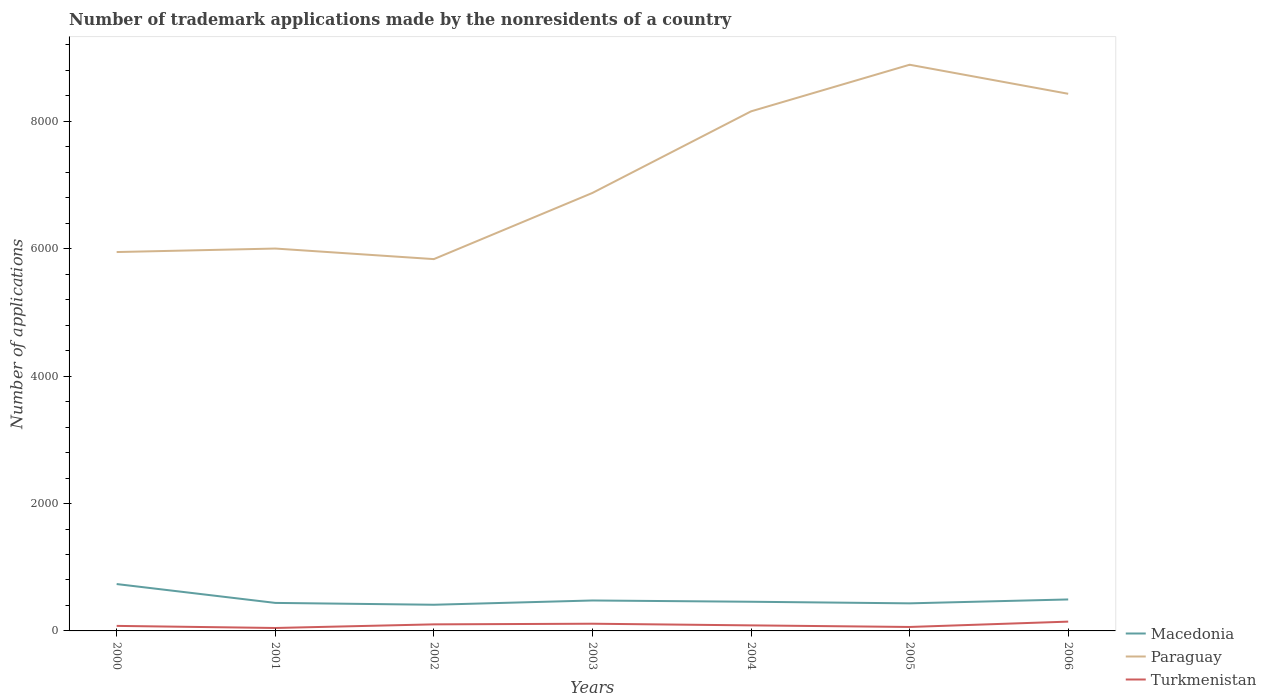How many different coloured lines are there?
Your answer should be compact. 3. Across all years, what is the maximum number of trademark applications made by the nonresidents in Macedonia?
Your answer should be compact. 411. What is the total number of trademark applications made by the nonresidents in Paraguay in the graph?
Offer a very short reply. -55. What is the difference between the highest and the second highest number of trademark applications made by the nonresidents in Paraguay?
Offer a terse response. 3052. Is the number of trademark applications made by the nonresidents in Macedonia strictly greater than the number of trademark applications made by the nonresidents in Turkmenistan over the years?
Provide a short and direct response. No. How many years are there in the graph?
Make the answer very short. 7. What is the difference between two consecutive major ticks on the Y-axis?
Provide a short and direct response. 2000. Does the graph contain any zero values?
Your answer should be very brief. No. Does the graph contain grids?
Your answer should be very brief. No. How are the legend labels stacked?
Your answer should be compact. Vertical. What is the title of the graph?
Your answer should be very brief. Number of trademark applications made by the nonresidents of a country. What is the label or title of the Y-axis?
Your response must be concise. Number of applications. What is the Number of applications of Macedonia in 2000?
Your answer should be compact. 736. What is the Number of applications in Paraguay in 2000?
Offer a terse response. 5949. What is the Number of applications in Turkmenistan in 2000?
Your answer should be very brief. 79. What is the Number of applications of Macedonia in 2001?
Provide a short and direct response. 440. What is the Number of applications in Paraguay in 2001?
Provide a short and direct response. 6004. What is the Number of applications in Macedonia in 2002?
Make the answer very short. 411. What is the Number of applications in Paraguay in 2002?
Provide a short and direct response. 5838. What is the Number of applications of Turkmenistan in 2002?
Offer a very short reply. 103. What is the Number of applications of Macedonia in 2003?
Provide a short and direct response. 478. What is the Number of applications of Paraguay in 2003?
Offer a very short reply. 6877. What is the Number of applications of Turkmenistan in 2003?
Offer a terse response. 113. What is the Number of applications in Macedonia in 2004?
Offer a very short reply. 458. What is the Number of applications of Paraguay in 2004?
Offer a very short reply. 8158. What is the Number of applications in Turkmenistan in 2004?
Offer a terse response. 87. What is the Number of applications in Macedonia in 2005?
Offer a very short reply. 433. What is the Number of applications of Paraguay in 2005?
Provide a short and direct response. 8890. What is the Number of applications of Turkmenistan in 2005?
Provide a short and direct response. 62. What is the Number of applications in Macedonia in 2006?
Your answer should be very brief. 494. What is the Number of applications in Paraguay in 2006?
Provide a succinct answer. 8434. What is the Number of applications in Turkmenistan in 2006?
Your answer should be compact. 146. Across all years, what is the maximum Number of applications in Macedonia?
Your response must be concise. 736. Across all years, what is the maximum Number of applications in Paraguay?
Offer a very short reply. 8890. Across all years, what is the maximum Number of applications in Turkmenistan?
Your answer should be compact. 146. Across all years, what is the minimum Number of applications in Macedonia?
Offer a very short reply. 411. Across all years, what is the minimum Number of applications of Paraguay?
Your response must be concise. 5838. Across all years, what is the minimum Number of applications in Turkmenistan?
Provide a succinct answer. 46. What is the total Number of applications of Macedonia in the graph?
Provide a succinct answer. 3450. What is the total Number of applications in Paraguay in the graph?
Your answer should be very brief. 5.02e+04. What is the total Number of applications of Turkmenistan in the graph?
Your answer should be compact. 636. What is the difference between the Number of applications in Macedonia in 2000 and that in 2001?
Make the answer very short. 296. What is the difference between the Number of applications of Paraguay in 2000 and that in 2001?
Provide a succinct answer. -55. What is the difference between the Number of applications in Turkmenistan in 2000 and that in 2001?
Give a very brief answer. 33. What is the difference between the Number of applications of Macedonia in 2000 and that in 2002?
Your answer should be compact. 325. What is the difference between the Number of applications in Paraguay in 2000 and that in 2002?
Offer a terse response. 111. What is the difference between the Number of applications in Turkmenistan in 2000 and that in 2002?
Provide a short and direct response. -24. What is the difference between the Number of applications of Macedonia in 2000 and that in 2003?
Offer a very short reply. 258. What is the difference between the Number of applications of Paraguay in 2000 and that in 2003?
Provide a short and direct response. -928. What is the difference between the Number of applications of Turkmenistan in 2000 and that in 2003?
Give a very brief answer. -34. What is the difference between the Number of applications of Macedonia in 2000 and that in 2004?
Keep it short and to the point. 278. What is the difference between the Number of applications of Paraguay in 2000 and that in 2004?
Your answer should be compact. -2209. What is the difference between the Number of applications in Turkmenistan in 2000 and that in 2004?
Offer a very short reply. -8. What is the difference between the Number of applications in Macedonia in 2000 and that in 2005?
Your answer should be very brief. 303. What is the difference between the Number of applications of Paraguay in 2000 and that in 2005?
Your response must be concise. -2941. What is the difference between the Number of applications in Turkmenistan in 2000 and that in 2005?
Provide a short and direct response. 17. What is the difference between the Number of applications in Macedonia in 2000 and that in 2006?
Make the answer very short. 242. What is the difference between the Number of applications of Paraguay in 2000 and that in 2006?
Make the answer very short. -2485. What is the difference between the Number of applications in Turkmenistan in 2000 and that in 2006?
Make the answer very short. -67. What is the difference between the Number of applications of Macedonia in 2001 and that in 2002?
Provide a succinct answer. 29. What is the difference between the Number of applications in Paraguay in 2001 and that in 2002?
Keep it short and to the point. 166. What is the difference between the Number of applications of Turkmenistan in 2001 and that in 2002?
Offer a very short reply. -57. What is the difference between the Number of applications in Macedonia in 2001 and that in 2003?
Your response must be concise. -38. What is the difference between the Number of applications in Paraguay in 2001 and that in 2003?
Your answer should be compact. -873. What is the difference between the Number of applications in Turkmenistan in 2001 and that in 2003?
Make the answer very short. -67. What is the difference between the Number of applications of Macedonia in 2001 and that in 2004?
Keep it short and to the point. -18. What is the difference between the Number of applications in Paraguay in 2001 and that in 2004?
Your answer should be very brief. -2154. What is the difference between the Number of applications of Turkmenistan in 2001 and that in 2004?
Your answer should be compact. -41. What is the difference between the Number of applications of Macedonia in 2001 and that in 2005?
Ensure brevity in your answer.  7. What is the difference between the Number of applications in Paraguay in 2001 and that in 2005?
Make the answer very short. -2886. What is the difference between the Number of applications of Macedonia in 2001 and that in 2006?
Give a very brief answer. -54. What is the difference between the Number of applications of Paraguay in 2001 and that in 2006?
Keep it short and to the point. -2430. What is the difference between the Number of applications in Turkmenistan in 2001 and that in 2006?
Offer a terse response. -100. What is the difference between the Number of applications in Macedonia in 2002 and that in 2003?
Provide a short and direct response. -67. What is the difference between the Number of applications of Paraguay in 2002 and that in 2003?
Provide a short and direct response. -1039. What is the difference between the Number of applications in Macedonia in 2002 and that in 2004?
Provide a short and direct response. -47. What is the difference between the Number of applications of Paraguay in 2002 and that in 2004?
Provide a succinct answer. -2320. What is the difference between the Number of applications of Paraguay in 2002 and that in 2005?
Provide a succinct answer. -3052. What is the difference between the Number of applications of Macedonia in 2002 and that in 2006?
Offer a terse response. -83. What is the difference between the Number of applications in Paraguay in 2002 and that in 2006?
Provide a short and direct response. -2596. What is the difference between the Number of applications of Turkmenistan in 2002 and that in 2006?
Give a very brief answer. -43. What is the difference between the Number of applications in Macedonia in 2003 and that in 2004?
Ensure brevity in your answer.  20. What is the difference between the Number of applications of Paraguay in 2003 and that in 2004?
Provide a short and direct response. -1281. What is the difference between the Number of applications of Macedonia in 2003 and that in 2005?
Ensure brevity in your answer.  45. What is the difference between the Number of applications in Paraguay in 2003 and that in 2005?
Your answer should be compact. -2013. What is the difference between the Number of applications in Macedonia in 2003 and that in 2006?
Offer a terse response. -16. What is the difference between the Number of applications of Paraguay in 2003 and that in 2006?
Your answer should be compact. -1557. What is the difference between the Number of applications of Turkmenistan in 2003 and that in 2006?
Your answer should be very brief. -33. What is the difference between the Number of applications in Paraguay in 2004 and that in 2005?
Provide a succinct answer. -732. What is the difference between the Number of applications of Macedonia in 2004 and that in 2006?
Offer a terse response. -36. What is the difference between the Number of applications in Paraguay in 2004 and that in 2006?
Provide a short and direct response. -276. What is the difference between the Number of applications in Turkmenistan in 2004 and that in 2006?
Make the answer very short. -59. What is the difference between the Number of applications of Macedonia in 2005 and that in 2006?
Keep it short and to the point. -61. What is the difference between the Number of applications of Paraguay in 2005 and that in 2006?
Provide a short and direct response. 456. What is the difference between the Number of applications of Turkmenistan in 2005 and that in 2006?
Offer a terse response. -84. What is the difference between the Number of applications of Macedonia in 2000 and the Number of applications of Paraguay in 2001?
Offer a terse response. -5268. What is the difference between the Number of applications in Macedonia in 2000 and the Number of applications in Turkmenistan in 2001?
Your response must be concise. 690. What is the difference between the Number of applications in Paraguay in 2000 and the Number of applications in Turkmenistan in 2001?
Provide a short and direct response. 5903. What is the difference between the Number of applications in Macedonia in 2000 and the Number of applications in Paraguay in 2002?
Ensure brevity in your answer.  -5102. What is the difference between the Number of applications of Macedonia in 2000 and the Number of applications of Turkmenistan in 2002?
Provide a succinct answer. 633. What is the difference between the Number of applications of Paraguay in 2000 and the Number of applications of Turkmenistan in 2002?
Provide a short and direct response. 5846. What is the difference between the Number of applications in Macedonia in 2000 and the Number of applications in Paraguay in 2003?
Provide a short and direct response. -6141. What is the difference between the Number of applications of Macedonia in 2000 and the Number of applications of Turkmenistan in 2003?
Offer a terse response. 623. What is the difference between the Number of applications of Paraguay in 2000 and the Number of applications of Turkmenistan in 2003?
Provide a succinct answer. 5836. What is the difference between the Number of applications in Macedonia in 2000 and the Number of applications in Paraguay in 2004?
Offer a very short reply. -7422. What is the difference between the Number of applications in Macedonia in 2000 and the Number of applications in Turkmenistan in 2004?
Your response must be concise. 649. What is the difference between the Number of applications of Paraguay in 2000 and the Number of applications of Turkmenistan in 2004?
Provide a succinct answer. 5862. What is the difference between the Number of applications in Macedonia in 2000 and the Number of applications in Paraguay in 2005?
Ensure brevity in your answer.  -8154. What is the difference between the Number of applications of Macedonia in 2000 and the Number of applications of Turkmenistan in 2005?
Make the answer very short. 674. What is the difference between the Number of applications in Paraguay in 2000 and the Number of applications in Turkmenistan in 2005?
Make the answer very short. 5887. What is the difference between the Number of applications in Macedonia in 2000 and the Number of applications in Paraguay in 2006?
Ensure brevity in your answer.  -7698. What is the difference between the Number of applications of Macedonia in 2000 and the Number of applications of Turkmenistan in 2006?
Offer a terse response. 590. What is the difference between the Number of applications in Paraguay in 2000 and the Number of applications in Turkmenistan in 2006?
Provide a short and direct response. 5803. What is the difference between the Number of applications of Macedonia in 2001 and the Number of applications of Paraguay in 2002?
Provide a short and direct response. -5398. What is the difference between the Number of applications in Macedonia in 2001 and the Number of applications in Turkmenistan in 2002?
Your answer should be very brief. 337. What is the difference between the Number of applications in Paraguay in 2001 and the Number of applications in Turkmenistan in 2002?
Offer a terse response. 5901. What is the difference between the Number of applications in Macedonia in 2001 and the Number of applications in Paraguay in 2003?
Make the answer very short. -6437. What is the difference between the Number of applications in Macedonia in 2001 and the Number of applications in Turkmenistan in 2003?
Your answer should be very brief. 327. What is the difference between the Number of applications in Paraguay in 2001 and the Number of applications in Turkmenistan in 2003?
Your answer should be compact. 5891. What is the difference between the Number of applications of Macedonia in 2001 and the Number of applications of Paraguay in 2004?
Provide a succinct answer. -7718. What is the difference between the Number of applications in Macedonia in 2001 and the Number of applications in Turkmenistan in 2004?
Make the answer very short. 353. What is the difference between the Number of applications in Paraguay in 2001 and the Number of applications in Turkmenistan in 2004?
Ensure brevity in your answer.  5917. What is the difference between the Number of applications in Macedonia in 2001 and the Number of applications in Paraguay in 2005?
Make the answer very short. -8450. What is the difference between the Number of applications in Macedonia in 2001 and the Number of applications in Turkmenistan in 2005?
Keep it short and to the point. 378. What is the difference between the Number of applications of Paraguay in 2001 and the Number of applications of Turkmenistan in 2005?
Provide a short and direct response. 5942. What is the difference between the Number of applications of Macedonia in 2001 and the Number of applications of Paraguay in 2006?
Your answer should be very brief. -7994. What is the difference between the Number of applications of Macedonia in 2001 and the Number of applications of Turkmenistan in 2006?
Your answer should be compact. 294. What is the difference between the Number of applications of Paraguay in 2001 and the Number of applications of Turkmenistan in 2006?
Provide a short and direct response. 5858. What is the difference between the Number of applications of Macedonia in 2002 and the Number of applications of Paraguay in 2003?
Your response must be concise. -6466. What is the difference between the Number of applications in Macedonia in 2002 and the Number of applications in Turkmenistan in 2003?
Give a very brief answer. 298. What is the difference between the Number of applications in Paraguay in 2002 and the Number of applications in Turkmenistan in 2003?
Make the answer very short. 5725. What is the difference between the Number of applications in Macedonia in 2002 and the Number of applications in Paraguay in 2004?
Keep it short and to the point. -7747. What is the difference between the Number of applications in Macedonia in 2002 and the Number of applications in Turkmenistan in 2004?
Make the answer very short. 324. What is the difference between the Number of applications of Paraguay in 2002 and the Number of applications of Turkmenistan in 2004?
Make the answer very short. 5751. What is the difference between the Number of applications of Macedonia in 2002 and the Number of applications of Paraguay in 2005?
Offer a very short reply. -8479. What is the difference between the Number of applications of Macedonia in 2002 and the Number of applications of Turkmenistan in 2005?
Ensure brevity in your answer.  349. What is the difference between the Number of applications of Paraguay in 2002 and the Number of applications of Turkmenistan in 2005?
Provide a short and direct response. 5776. What is the difference between the Number of applications of Macedonia in 2002 and the Number of applications of Paraguay in 2006?
Keep it short and to the point. -8023. What is the difference between the Number of applications of Macedonia in 2002 and the Number of applications of Turkmenistan in 2006?
Your answer should be very brief. 265. What is the difference between the Number of applications of Paraguay in 2002 and the Number of applications of Turkmenistan in 2006?
Give a very brief answer. 5692. What is the difference between the Number of applications in Macedonia in 2003 and the Number of applications in Paraguay in 2004?
Your answer should be very brief. -7680. What is the difference between the Number of applications of Macedonia in 2003 and the Number of applications of Turkmenistan in 2004?
Provide a short and direct response. 391. What is the difference between the Number of applications in Paraguay in 2003 and the Number of applications in Turkmenistan in 2004?
Offer a terse response. 6790. What is the difference between the Number of applications of Macedonia in 2003 and the Number of applications of Paraguay in 2005?
Keep it short and to the point. -8412. What is the difference between the Number of applications of Macedonia in 2003 and the Number of applications of Turkmenistan in 2005?
Your response must be concise. 416. What is the difference between the Number of applications of Paraguay in 2003 and the Number of applications of Turkmenistan in 2005?
Give a very brief answer. 6815. What is the difference between the Number of applications in Macedonia in 2003 and the Number of applications in Paraguay in 2006?
Offer a very short reply. -7956. What is the difference between the Number of applications in Macedonia in 2003 and the Number of applications in Turkmenistan in 2006?
Your answer should be very brief. 332. What is the difference between the Number of applications of Paraguay in 2003 and the Number of applications of Turkmenistan in 2006?
Keep it short and to the point. 6731. What is the difference between the Number of applications in Macedonia in 2004 and the Number of applications in Paraguay in 2005?
Your answer should be compact. -8432. What is the difference between the Number of applications of Macedonia in 2004 and the Number of applications of Turkmenistan in 2005?
Provide a succinct answer. 396. What is the difference between the Number of applications of Paraguay in 2004 and the Number of applications of Turkmenistan in 2005?
Keep it short and to the point. 8096. What is the difference between the Number of applications in Macedonia in 2004 and the Number of applications in Paraguay in 2006?
Give a very brief answer. -7976. What is the difference between the Number of applications in Macedonia in 2004 and the Number of applications in Turkmenistan in 2006?
Give a very brief answer. 312. What is the difference between the Number of applications in Paraguay in 2004 and the Number of applications in Turkmenistan in 2006?
Make the answer very short. 8012. What is the difference between the Number of applications of Macedonia in 2005 and the Number of applications of Paraguay in 2006?
Your answer should be very brief. -8001. What is the difference between the Number of applications of Macedonia in 2005 and the Number of applications of Turkmenistan in 2006?
Your answer should be very brief. 287. What is the difference between the Number of applications of Paraguay in 2005 and the Number of applications of Turkmenistan in 2006?
Ensure brevity in your answer.  8744. What is the average Number of applications of Macedonia per year?
Your answer should be compact. 492.86. What is the average Number of applications of Paraguay per year?
Your answer should be very brief. 7164.29. What is the average Number of applications of Turkmenistan per year?
Offer a very short reply. 90.86. In the year 2000, what is the difference between the Number of applications of Macedonia and Number of applications of Paraguay?
Make the answer very short. -5213. In the year 2000, what is the difference between the Number of applications in Macedonia and Number of applications in Turkmenistan?
Make the answer very short. 657. In the year 2000, what is the difference between the Number of applications of Paraguay and Number of applications of Turkmenistan?
Provide a short and direct response. 5870. In the year 2001, what is the difference between the Number of applications in Macedonia and Number of applications in Paraguay?
Make the answer very short. -5564. In the year 2001, what is the difference between the Number of applications in Macedonia and Number of applications in Turkmenistan?
Your answer should be very brief. 394. In the year 2001, what is the difference between the Number of applications in Paraguay and Number of applications in Turkmenistan?
Offer a terse response. 5958. In the year 2002, what is the difference between the Number of applications of Macedonia and Number of applications of Paraguay?
Make the answer very short. -5427. In the year 2002, what is the difference between the Number of applications in Macedonia and Number of applications in Turkmenistan?
Your answer should be compact. 308. In the year 2002, what is the difference between the Number of applications in Paraguay and Number of applications in Turkmenistan?
Your answer should be very brief. 5735. In the year 2003, what is the difference between the Number of applications in Macedonia and Number of applications in Paraguay?
Ensure brevity in your answer.  -6399. In the year 2003, what is the difference between the Number of applications in Macedonia and Number of applications in Turkmenistan?
Provide a succinct answer. 365. In the year 2003, what is the difference between the Number of applications of Paraguay and Number of applications of Turkmenistan?
Provide a short and direct response. 6764. In the year 2004, what is the difference between the Number of applications of Macedonia and Number of applications of Paraguay?
Provide a succinct answer. -7700. In the year 2004, what is the difference between the Number of applications in Macedonia and Number of applications in Turkmenistan?
Offer a very short reply. 371. In the year 2004, what is the difference between the Number of applications in Paraguay and Number of applications in Turkmenistan?
Make the answer very short. 8071. In the year 2005, what is the difference between the Number of applications of Macedonia and Number of applications of Paraguay?
Ensure brevity in your answer.  -8457. In the year 2005, what is the difference between the Number of applications in Macedonia and Number of applications in Turkmenistan?
Your response must be concise. 371. In the year 2005, what is the difference between the Number of applications in Paraguay and Number of applications in Turkmenistan?
Provide a succinct answer. 8828. In the year 2006, what is the difference between the Number of applications of Macedonia and Number of applications of Paraguay?
Your answer should be compact. -7940. In the year 2006, what is the difference between the Number of applications in Macedonia and Number of applications in Turkmenistan?
Your answer should be compact. 348. In the year 2006, what is the difference between the Number of applications in Paraguay and Number of applications in Turkmenistan?
Give a very brief answer. 8288. What is the ratio of the Number of applications of Macedonia in 2000 to that in 2001?
Provide a succinct answer. 1.67. What is the ratio of the Number of applications of Paraguay in 2000 to that in 2001?
Your answer should be very brief. 0.99. What is the ratio of the Number of applications in Turkmenistan in 2000 to that in 2001?
Your response must be concise. 1.72. What is the ratio of the Number of applications in Macedonia in 2000 to that in 2002?
Give a very brief answer. 1.79. What is the ratio of the Number of applications in Paraguay in 2000 to that in 2002?
Your answer should be compact. 1.02. What is the ratio of the Number of applications of Turkmenistan in 2000 to that in 2002?
Provide a succinct answer. 0.77. What is the ratio of the Number of applications in Macedonia in 2000 to that in 2003?
Keep it short and to the point. 1.54. What is the ratio of the Number of applications in Paraguay in 2000 to that in 2003?
Offer a terse response. 0.87. What is the ratio of the Number of applications in Turkmenistan in 2000 to that in 2003?
Your answer should be very brief. 0.7. What is the ratio of the Number of applications in Macedonia in 2000 to that in 2004?
Your response must be concise. 1.61. What is the ratio of the Number of applications of Paraguay in 2000 to that in 2004?
Your answer should be very brief. 0.73. What is the ratio of the Number of applications in Turkmenistan in 2000 to that in 2004?
Give a very brief answer. 0.91. What is the ratio of the Number of applications of Macedonia in 2000 to that in 2005?
Give a very brief answer. 1.7. What is the ratio of the Number of applications in Paraguay in 2000 to that in 2005?
Provide a short and direct response. 0.67. What is the ratio of the Number of applications in Turkmenistan in 2000 to that in 2005?
Make the answer very short. 1.27. What is the ratio of the Number of applications of Macedonia in 2000 to that in 2006?
Offer a terse response. 1.49. What is the ratio of the Number of applications in Paraguay in 2000 to that in 2006?
Keep it short and to the point. 0.71. What is the ratio of the Number of applications of Turkmenistan in 2000 to that in 2006?
Ensure brevity in your answer.  0.54. What is the ratio of the Number of applications of Macedonia in 2001 to that in 2002?
Provide a short and direct response. 1.07. What is the ratio of the Number of applications in Paraguay in 2001 to that in 2002?
Your response must be concise. 1.03. What is the ratio of the Number of applications of Turkmenistan in 2001 to that in 2002?
Provide a succinct answer. 0.45. What is the ratio of the Number of applications of Macedonia in 2001 to that in 2003?
Make the answer very short. 0.92. What is the ratio of the Number of applications of Paraguay in 2001 to that in 2003?
Give a very brief answer. 0.87. What is the ratio of the Number of applications in Turkmenistan in 2001 to that in 2003?
Offer a terse response. 0.41. What is the ratio of the Number of applications in Macedonia in 2001 to that in 2004?
Give a very brief answer. 0.96. What is the ratio of the Number of applications in Paraguay in 2001 to that in 2004?
Ensure brevity in your answer.  0.74. What is the ratio of the Number of applications in Turkmenistan in 2001 to that in 2004?
Make the answer very short. 0.53. What is the ratio of the Number of applications in Macedonia in 2001 to that in 2005?
Keep it short and to the point. 1.02. What is the ratio of the Number of applications in Paraguay in 2001 to that in 2005?
Offer a terse response. 0.68. What is the ratio of the Number of applications in Turkmenistan in 2001 to that in 2005?
Provide a short and direct response. 0.74. What is the ratio of the Number of applications in Macedonia in 2001 to that in 2006?
Your answer should be very brief. 0.89. What is the ratio of the Number of applications of Paraguay in 2001 to that in 2006?
Give a very brief answer. 0.71. What is the ratio of the Number of applications in Turkmenistan in 2001 to that in 2006?
Keep it short and to the point. 0.32. What is the ratio of the Number of applications in Macedonia in 2002 to that in 2003?
Offer a terse response. 0.86. What is the ratio of the Number of applications in Paraguay in 2002 to that in 2003?
Keep it short and to the point. 0.85. What is the ratio of the Number of applications in Turkmenistan in 2002 to that in 2003?
Offer a terse response. 0.91. What is the ratio of the Number of applications of Macedonia in 2002 to that in 2004?
Make the answer very short. 0.9. What is the ratio of the Number of applications of Paraguay in 2002 to that in 2004?
Provide a short and direct response. 0.72. What is the ratio of the Number of applications of Turkmenistan in 2002 to that in 2004?
Your answer should be very brief. 1.18. What is the ratio of the Number of applications of Macedonia in 2002 to that in 2005?
Offer a terse response. 0.95. What is the ratio of the Number of applications of Paraguay in 2002 to that in 2005?
Provide a short and direct response. 0.66. What is the ratio of the Number of applications in Turkmenistan in 2002 to that in 2005?
Provide a short and direct response. 1.66. What is the ratio of the Number of applications in Macedonia in 2002 to that in 2006?
Make the answer very short. 0.83. What is the ratio of the Number of applications of Paraguay in 2002 to that in 2006?
Give a very brief answer. 0.69. What is the ratio of the Number of applications in Turkmenistan in 2002 to that in 2006?
Your answer should be compact. 0.71. What is the ratio of the Number of applications of Macedonia in 2003 to that in 2004?
Make the answer very short. 1.04. What is the ratio of the Number of applications in Paraguay in 2003 to that in 2004?
Make the answer very short. 0.84. What is the ratio of the Number of applications in Turkmenistan in 2003 to that in 2004?
Offer a terse response. 1.3. What is the ratio of the Number of applications in Macedonia in 2003 to that in 2005?
Offer a very short reply. 1.1. What is the ratio of the Number of applications of Paraguay in 2003 to that in 2005?
Offer a very short reply. 0.77. What is the ratio of the Number of applications of Turkmenistan in 2003 to that in 2005?
Provide a succinct answer. 1.82. What is the ratio of the Number of applications in Macedonia in 2003 to that in 2006?
Offer a terse response. 0.97. What is the ratio of the Number of applications in Paraguay in 2003 to that in 2006?
Make the answer very short. 0.82. What is the ratio of the Number of applications in Turkmenistan in 2003 to that in 2006?
Offer a very short reply. 0.77. What is the ratio of the Number of applications in Macedonia in 2004 to that in 2005?
Give a very brief answer. 1.06. What is the ratio of the Number of applications in Paraguay in 2004 to that in 2005?
Offer a very short reply. 0.92. What is the ratio of the Number of applications of Turkmenistan in 2004 to that in 2005?
Offer a very short reply. 1.4. What is the ratio of the Number of applications in Macedonia in 2004 to that in 2006?
Ensure brevity in your answer.  0.93. What is the ratio of the Number of applications in Paraguay in 2004 to that in 2006?
Provide a succinct answer. 0.97. What is the ratio of the Number of applications of Turkmenistan in 2004 to that in 2006?
Ensure brevity in your answer.  0.6. What is the ratio of the Number of applications of Macedonia in 2005 to that in 2006?
Offer a very short reply. 0.88. What is the ratio of the Number of applications in Paraguay in 2005 to that in 2006?
Make the answer very short. 1.05. What is the ratio of the Number of applications in Turkmenistan in 2005 to that in 2006?
Your answer should be compact. 0.42. What is the difference between the highest and the second highest Number of applications in Macedonia?
Keep it short and to the point. 242. What is the difference between the highest and the second highest Number of applications of Paraguay?
Your answer should be compact. 456. What is the difference between the highest and the lowest Number of applications of Macedonia?
Provide a succinct answer. 325. What is the difference between the highest and the lowest Number of applications of Paraguay?
Ensure brevity in your answer.  3052. 